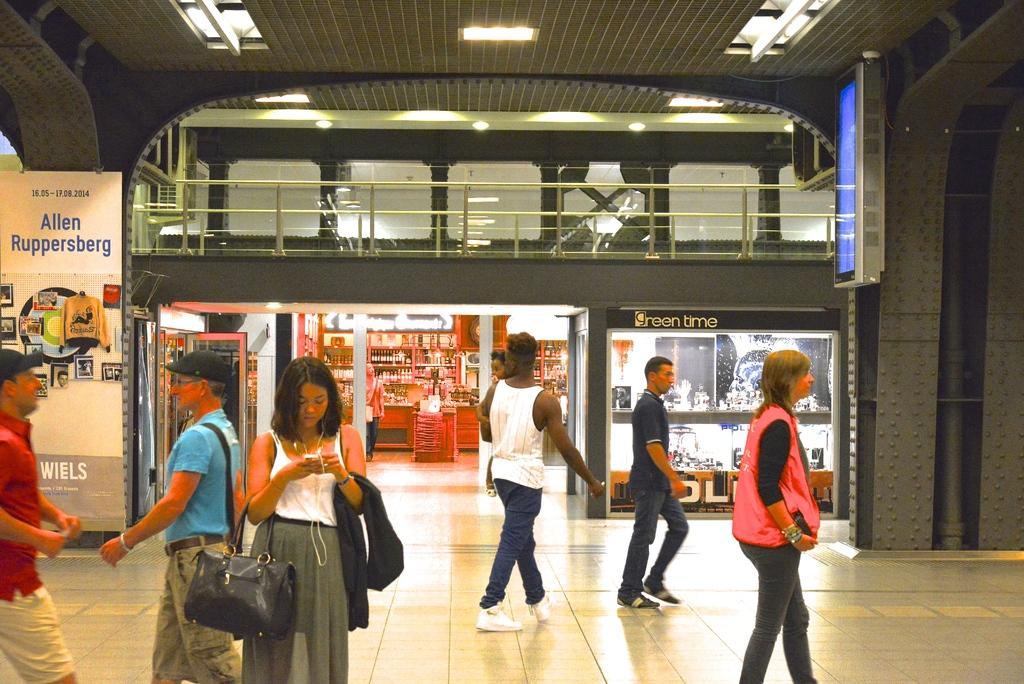What are the people in the image doing? There are people standing and walking in the image. Can you describe the location where the people are? The location appears to be a mall. What type of band can be heard playing in the image? There is no band present in the image, and therefore no music can be heard. 